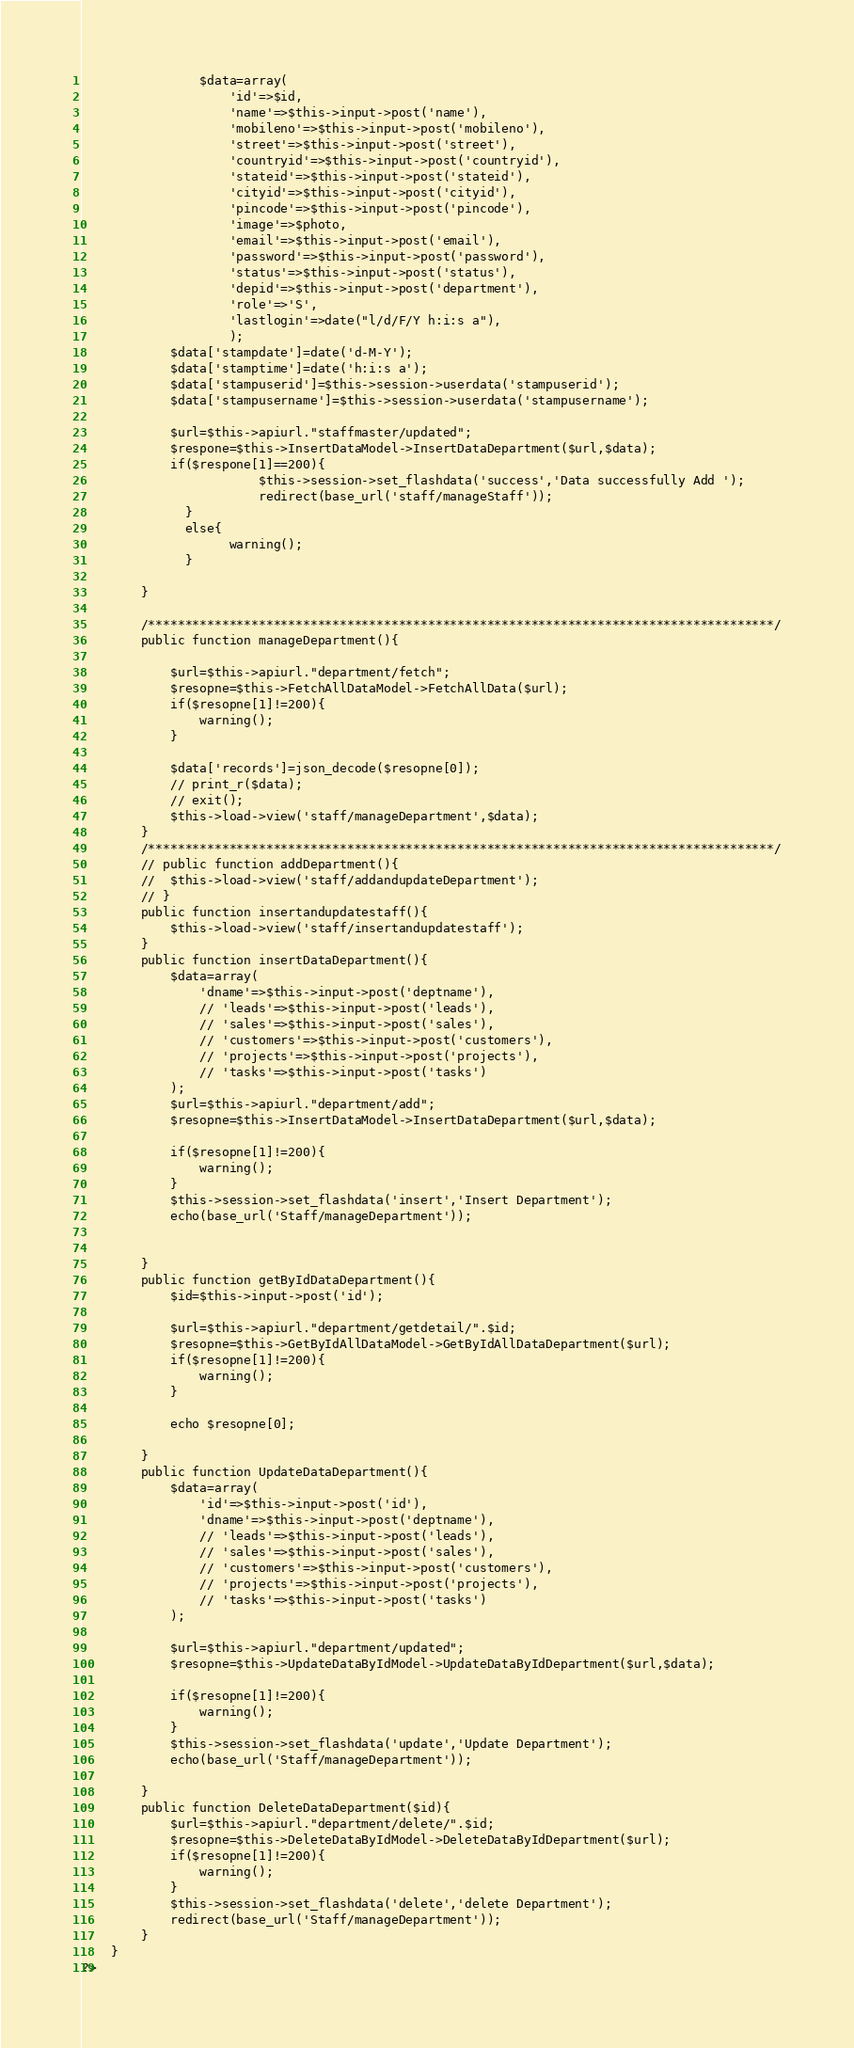Convert code to text. <code><loc_0><loc_0><loc_500><loc_500><_PHP_>				$data=array(
					'id'=>$id,
					'name'=>$this->input->post('name'),
					'mobileno'=>$this->input->post('mobileno'),
					'street'=>$this->input->post('street'),
					'countryid'=>$this->input->post('countryid'),
					'stateid'=>$this->input->post('stateid'),
					'cityid'=>$this->input->post('cityid'),
					'pincode'=>$this->input->post('pincode'),
					'image'=>$photo,
					'email'=>$this->input->post('email'),
					'password'=>$this->input->post('password'),
					'status'=>$this->input->post('status'),
					'depid'=>$this->input->post('department'),
					'role'=>'S',
					'lastlogin'=>date("l/d/F/Y h:i:s a"),
					);
			$data['stampdate']=date('d-M-Y');
			$data['stamptime']=date('h:i:s a');
			$data['stampuserid']=$this->session->userdata('stampuserid');
			$data['stampusername']=$this->session->userdata('stampusername');

			$url=$this->apiurl."staffmaster/updated";
			$respone=$this->InsertDataModel->InsertDataDepartment($url,$data);
			if($respone[1]==200){
						$this->session->set_flashdata('success','Data successfully Add ');
						redirect(base_url('staff/manageStaff'));
              }
              else{
                    warning();
              }

		}
		
		/*************************************************************************************/
		public function manageDepartment(){
			
			$url=$this->apiurl."department/fetch";
			$resopne=$this->FetchAllDataModel->FetchAllData($url);
			if($resopne[1]!=200){
				warning();
			}

			$data['records']=json_decode($resopne[0]);
			// print_r($data);
			// exit();
			$this->load->view('staff/manageDepartment',$data);
		}
		/*************************************************************************************/
		// public function addDepartment(){
		// 	$this->load->view('staff/addandupdateDepartment');
		// }
		public function insertandupdatestaff(){
			$this->load->view('staff/insertandupdatestaff');	
		}
		public function insertDataDepartment(){
			$data=array(
				'dname'=>$this->input->post('deptname'),
				// 'leads'=>$this->input->post('leads'),
				// 'sales'=>$this->input->post('sales'),
				// 'customers'=>$this->input->post('customers'),
				// 'projects'=>$this->input->post('projects'),
				// 'tasks'=>$this->input->post('tasks')
			);
			$url=$this->apiurl."department/add";
			$resopne=$this->InsertDataModel->InsertDataDepartment($url,$data);
			
			if($resopne[1]!=200){
				warning();
			}
			$this->session->set_flashdata('insert','Insert Department');
			echo(base_url('Staff/manageDepartment')); 

		
		}
		public function getByIdDataDepartment(){
			$id=$this->input->post('id');

			$url=$this->apiurl."department/getdetail/".$id;
			$resopne=$this->GetByIdAllDataModel->GetByIdAllDataDepartment($url);
			if($resopne[1]!=200){
				warning();
			}

			echo $resopne[0];
			
		}
		public function UpdateDataDepartment(){
			$data=array(
				'id'=>$this->input->post('id'),
				'dname'=>$this->input->post('deptname'),
				// 'leads'=>$this->input->post('leads'),
				// 'sales'=>$this->input->post('sales'),
				// 'customers'=>$this->input->post('customers'),
				// 'projects'=>$this->input->post('projects'),
				// 'tasks'=>$this->input->post('tasks')
			);

			$url=$this->apiurl."department/updated";
			$resopne=$this->UpdateDataByIdModel->UpdateDataByIdDepartment($url,$data);
			
			if($resopne[1]!=200){
				warning();
			}
			$this->session->set_flashdata('update','Update Department');
			echo(base_url('Staff/manageDepartment'));

		}
		public function DeleteDataDepartment($id){
			$url=$this->apiurl."department/delete/".$id;
			$resopne=$this->DeleteDataByIdModel->DeleteDataByIdDepartment($url);
			if($resopne[1]!=200){
				warning();
			}
			$this->session->set_flashdata('delete','delete Department');
			redirect(base_url('Staff/manageDepartment'));
		}
	}
?>
</code> 